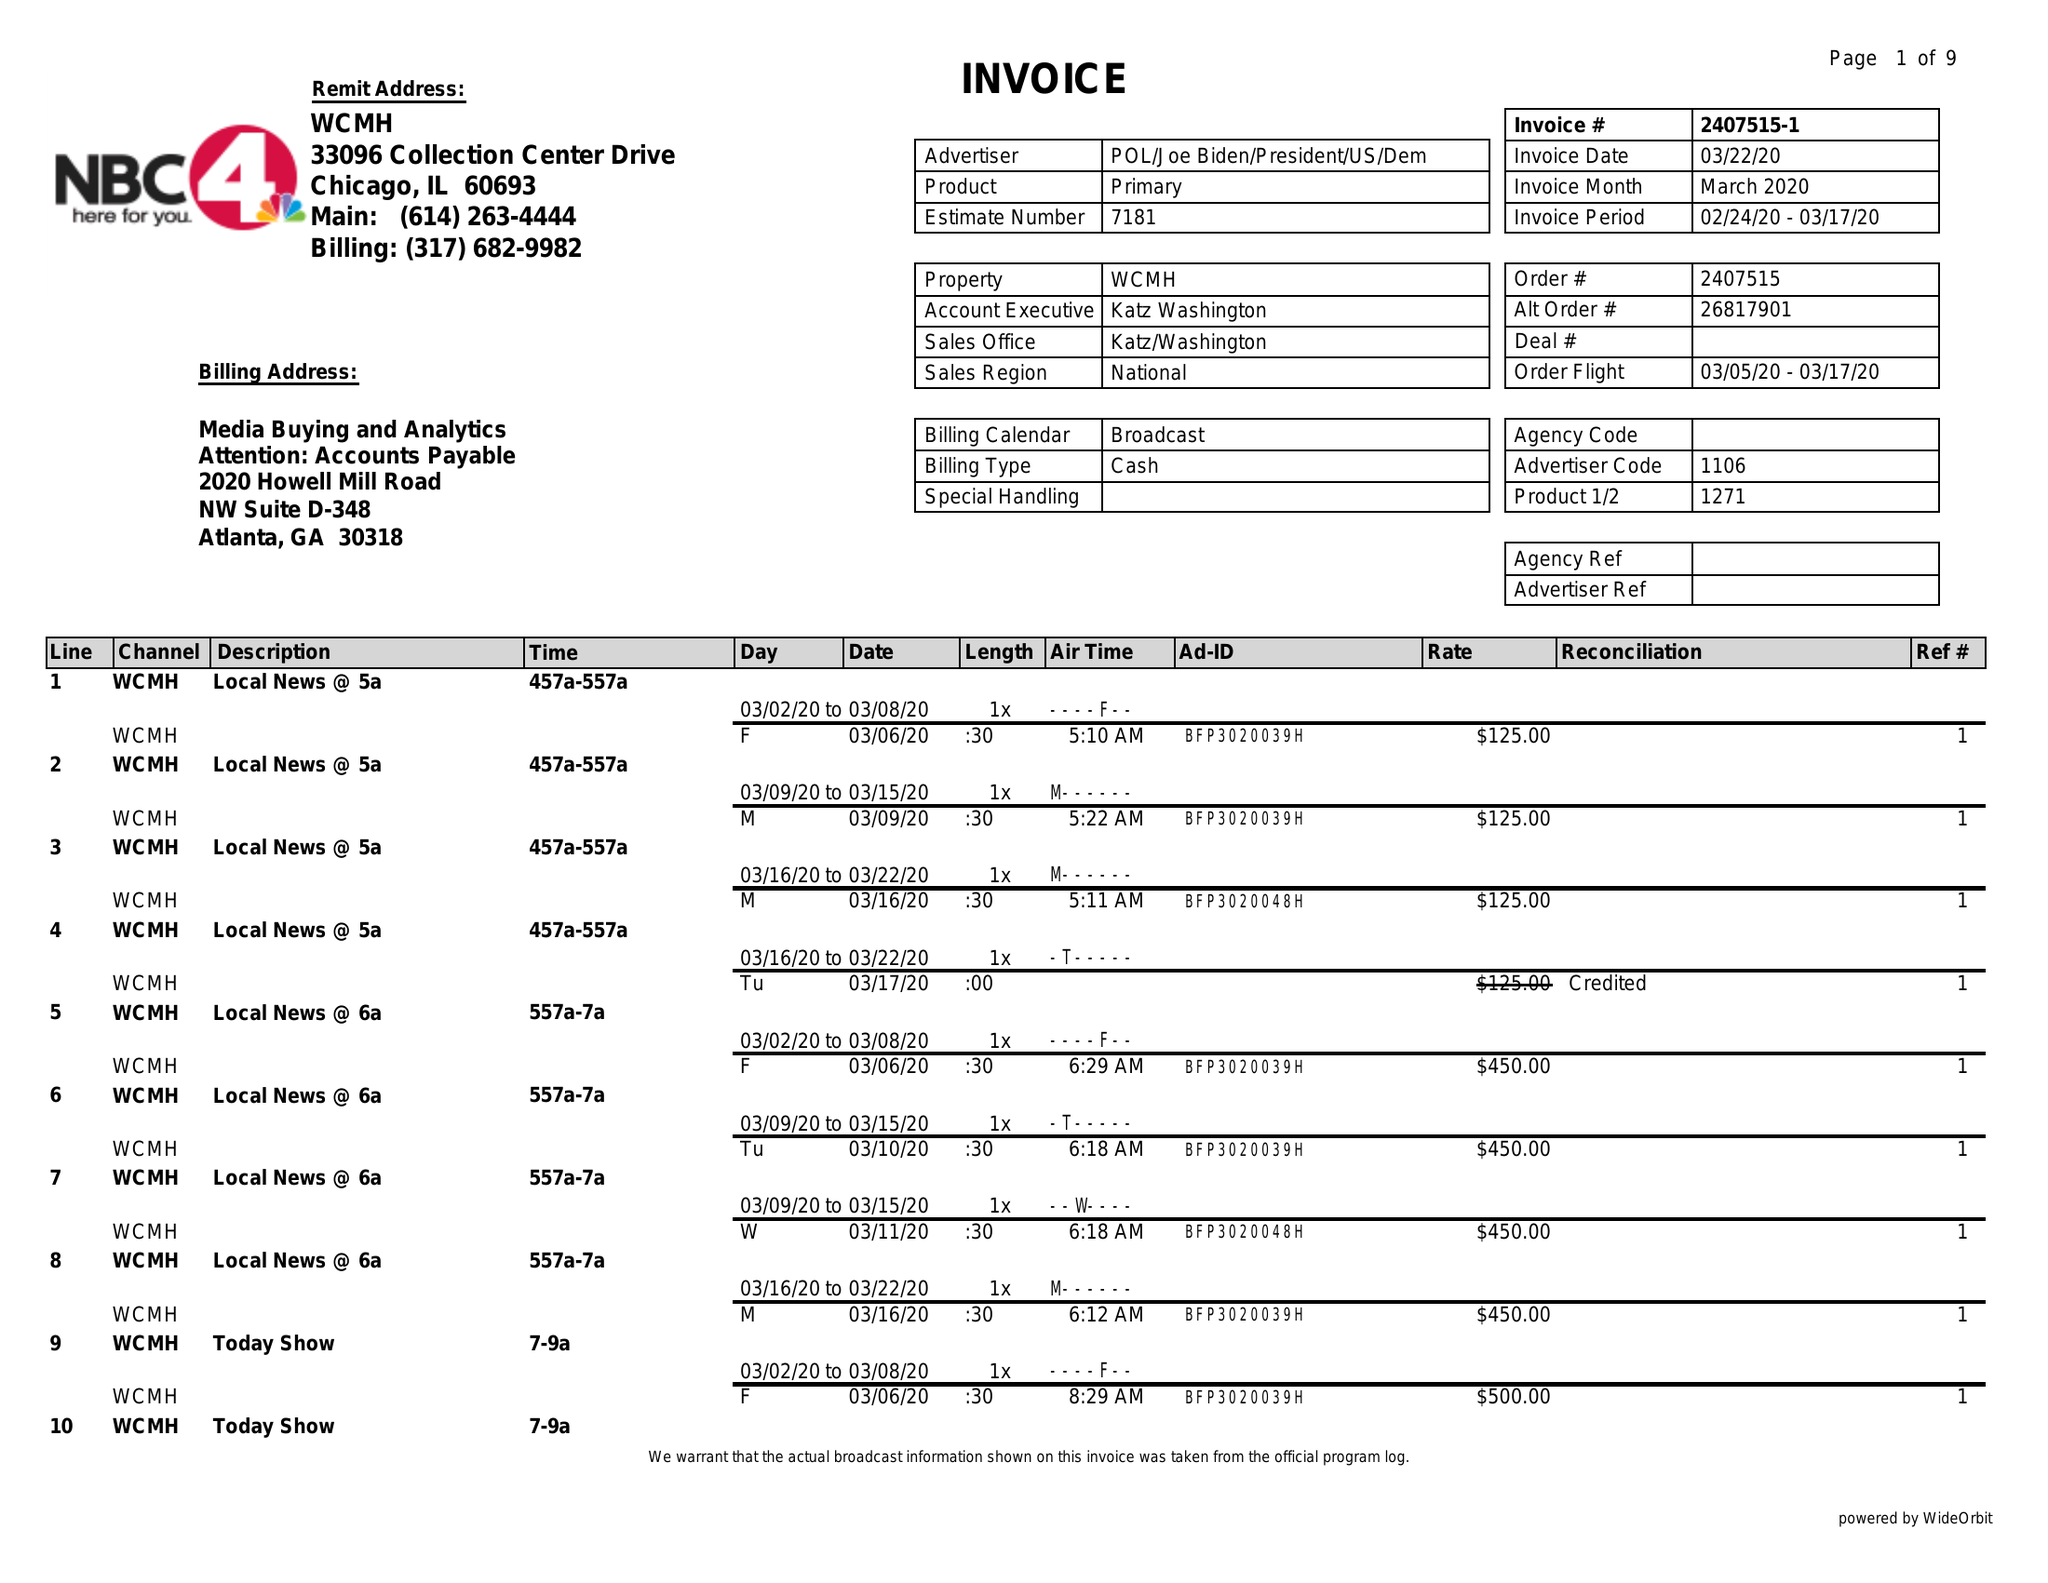What is the value for the advertiser?
Answer the question using a single word or phrase. POL/JOEBIDEN/PRESIDENT/US/DEM 